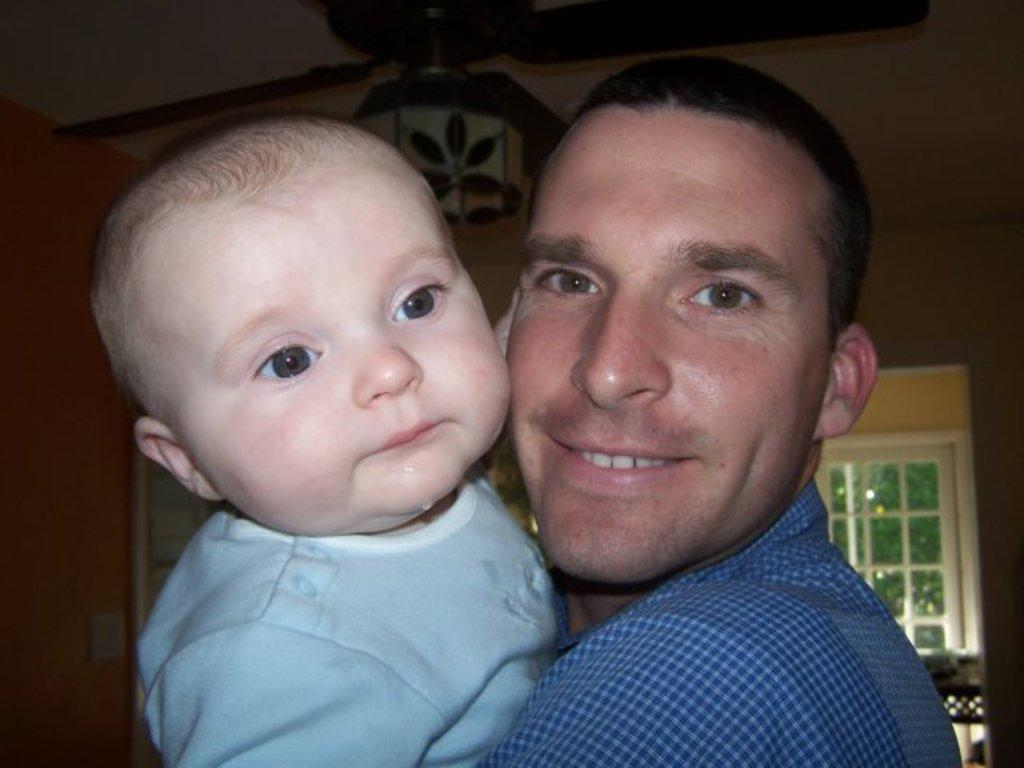Who is present in the image? There is a man in the image. What is the man holding? The man is holding a baby. What can be seen in the background of the image? There is a window and a fan attached to the roof in the background of the image. What page is the man turning in the image? There is no reference to a book or page in the image, so it is not possible to answer that question. 